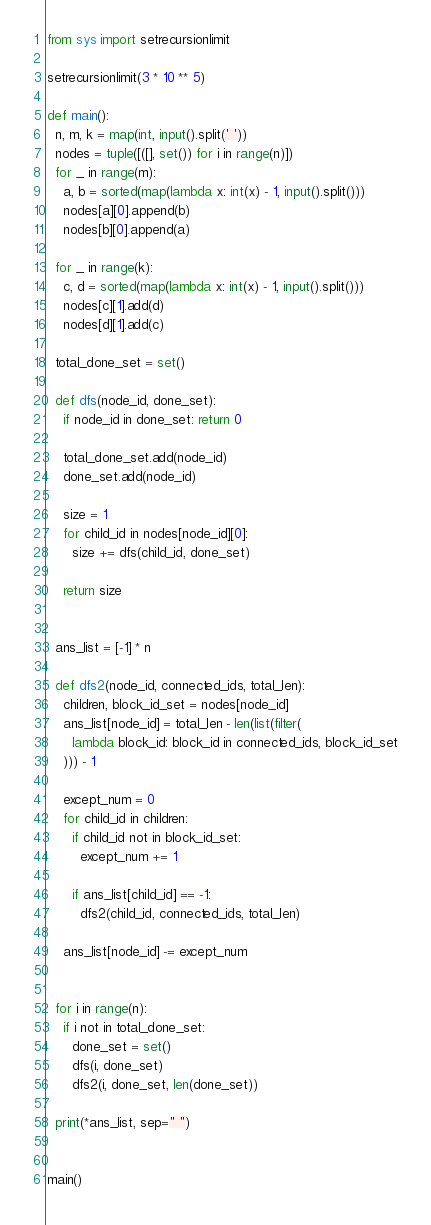<code> <loc_0><loc_0><loc_500><loc_500><_Python_>from sys import setrecursionlimit

setrecursionlimit(3 * 10 ** 5)

def main():
  n, m, k = map(int, input().split(' '))
  nodes = tuple([([], set()) for i in range(n)])
  for _ in range(m):
    a, b = sorted(map(lambda x: int(x) - 1, input().split()))
    nodes[a][0].append(b)
    nodes[b][0].append(a)

  for _ in range(k):
    c, d = sorted(map(lambda x: int(x) - 1, input().split()))
    nodes[c][1].add(d)
    nodes[d][1].add(c)

  total_done_set = set()

  def dfs(node_id, done_set):
    if node_id in done_set: return 0

    total_done_set.add(node_id)
    done_set.add(node_id)

    size = 1
    for child_id in nodes[node_id][0]:
      size += dfs(child_id, done_set)

    return size


  ans_list = [-1] * n

  def dfs2(node_id, connected_ids, total_len):
    children, block_id_set = nodes[node_id]
    ans_list[node_id] = total_len - len(list(filter(
      lambda block_id: block_id in connected_ids, block_id_set
    ))) - 1

    except_num = 0
    for child_id in children:
      if child_id not in block_id_set:
        except_num += 1

      if ans_list[child_id] == -1:
        dfs2(child_id, connected_ids, total_len)

    ans_list[node_id] -= except_num


  for i in range(n):
    if i not in total_done_set:
      done_set = set()
      dfs(i, done_set)
      dfs2(i, done_set, len(done_set))

  print(*ans_list, sep=" ")


main()
</code> 